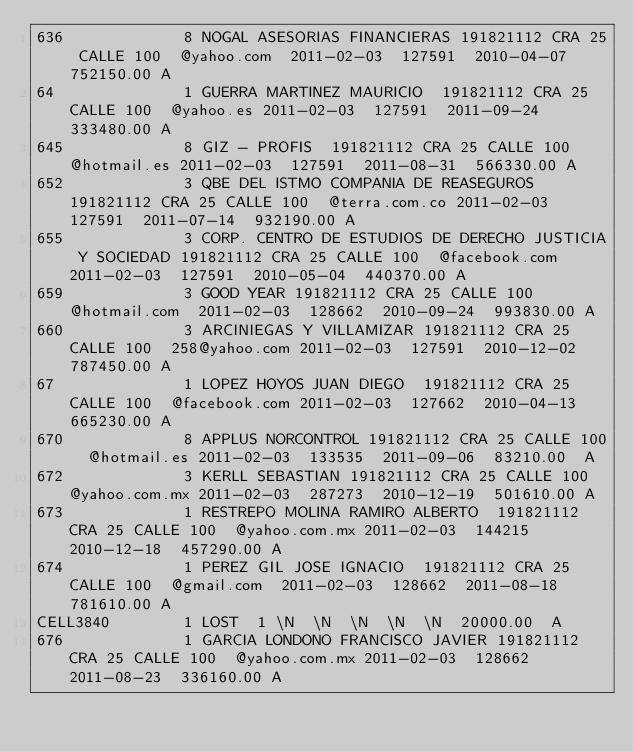Convert code to text. <code><loc_0><loc_0><loc_500><loc_500><_SQL_>636            	8	NOGAL ASESORIAS FINANCIERAS	191821112	CRA 25 CALLE 100	@yahoo.com	2011-02-03	127591	2010-04-07	752150.00	A
64             	1	GUERRA MARTINEZ MAURICIO	191821112	CRA 25 CALLE 100	@yahoo.es	2011-02-03	127591	2011-09-24	333480.00	A
645            	8	GIZ - PROFIS	191821112	CRA 25 CALLE 100	@hotmail.es	2011-02-03	127591	2011-08-31	566330.00	A
652            	3	QBE DEL ISTMO COMPANIA DE REASEGUROS 	191821112	CRA 25 CALLE 100	@terra.com.co	2011-02-03	127591	2011-07-14	932190.00	A
655            	3	CORP. CENTRO DE ESTUDIOS DE DERECHO JUSTICIA Y SOCIEDAD	191821112	CRA 25 CALLE 100	@facebook.com	2011-02-03	127591	2010-05-04	440370.00	A
659            	3	GOOD YEAR	191821112	CRA 25 CALLE 100	@hotmail.com	2011-02-03	128662	2010-09-24	993830.00	A
660            	3	ARCINIEGAS Y VILLAMIZAR	191821112	CRA 25 CALLE 100	258@yahoo.com	2011-02-03	127591	2010-12-02	787450.00	A
67             	1	LOPEZ HOYOS JUAN DIEGO	191821112	CRA 25 CALLE 100	@facebook.com	2011-02-03	127662	2010-04-13	665230.00	A
670            	8	APPLUS NORCONTROL	191821112	CRA 25 CALLE 100	@hotmail.es	2011-02-03	133535	2011-09-06	83210.00	A
672            	3	KERLL SEBASTIAN	191821112	CRA 25 CALLE 100	@yahoo.com.mx	2011-02-03	287273	2010-12-19	501610.00	A
673            	1	RESTREPO MOLINA RAMIRO ALBERTO	191821112	CRA 25 CALLE 100	@yahoo.com.mx	2011-02-03	144215	2010-12-18	457290.00	A
674            	1	PEREZ GIL JOSE IGNACIO	191821112	CRA 25 CALLE 100	@gmail.com	2011-02-03	128662	2011-08-18	781610.00	A
CELL3840       	1	LOST	1	\N	\N	\N	\N	\N	20000.00	A
676            	1	GARCIA LONDONO FRANCISCO JAVIER	191821112	CRA 25 CALLE 100	@yahoo.com.mx	2011-02-03	128662	2011-08-23	336160.00	A</code> 